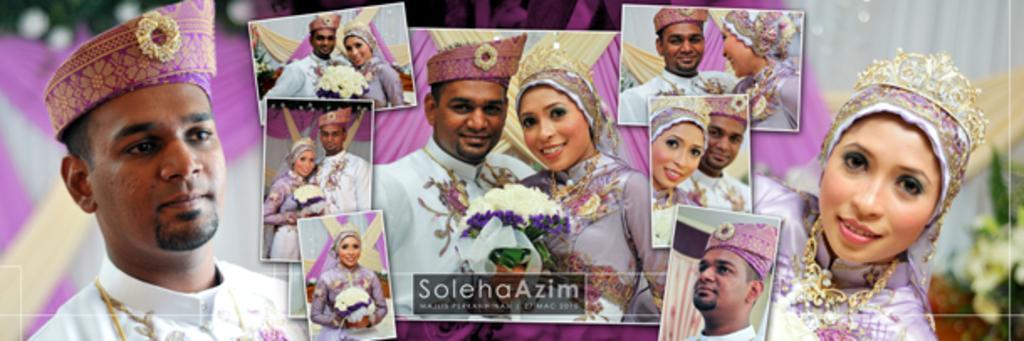How would you summarize this image in a sentence or two? In this image I can see a man and a woman. I can also see few photos and in these photos I can see people. I can also see smile on their faces and here I can see watermark. I can also see this image is blurry from background. 